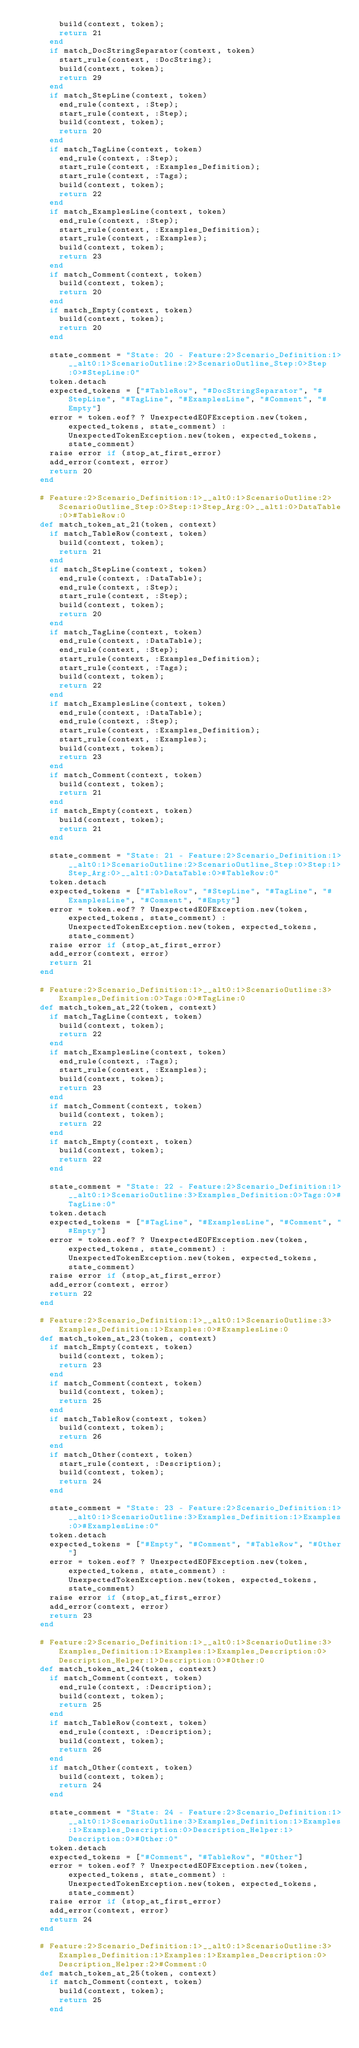Convert code to text. <code><loc_0><loc_0><loc_500><loc_500><_Ruby_>        build(context, token);
        return 21
      end
      if match_DocStringSeparator(context, token)
        start_rule(context, :DocString);
        build(context, token);
        return 29
      end
      if match_StepLine(context, token)
        end_rule(context, :Step);
        start_rule(context, :Step);
        build(context, token);
        return 20
      end
      if match_TagLine(context, token)
        end_rule(context, :Step);
        start_rule(context, :Examples_Definition);
        start_rule(context, :Tags);
        build(context, token);
        return 22
      end
      if match_ExamplesLine(context, token)
        end_rule(context, :Step);
        start_rule(context, :Examples_Definition);
        start_rule(context, :Examples);
        build(context, token);
        return 23
      end
      if match_Comment(context, token)
        build(context, token);
        return 20
      end
      if match_Empty(context, token)
        build(context, token);
        return 20
      end
      
      state_comment = "State: 20 - Feature:2>Scenario_Definition:1>__alt0:1>ScenarioOutline:2>ScenarioOutline_Step:0>Step:0>#StepLine:0"
      token.detach
      expected_tokens = ["#TableRow", "#DocStringSeparator", "#StepLine", "#TagLine", "#ExamplesLine", "#Comment", "#Empty"]
      error = token.eof? ? UnexpectedEOFException.new(token, expected_tokens, state_comment) : UnexpectedTokenException.new(token, expected_tokens, state_comment)
      raise error if (stop_at_first_error)
      add_error(context, error)
      return 20
    end

    # Feature:2>Scenario_Definition:1>__alt0:1>ScenarioOutline:2>ScenarioOutline_Step:0>Step:1>Step_Arg:0>__alt1:0>DataTable:0>#TableRow:0
    def match_token_at_21(token, context)
      if match_TableRow(context, token)
        build(context, token);
        return 21
      end
      if match_StepLine(context, token)
        end_rule(context, :DataTable);
        end_rule(context, :Step);
        start_rule(context, :Step);
        build(context, token);
        return 20
      end
      if match_TagLine(context, token)
        end_rule(context, :DataTable);
        end_rule(context, :Step);
        start_rule(context, :Examples_Definition);
        start_rule(context, :Tags);
        build(context, token);
        return 22
      end
      if match_ExamplesLine(context, token)
        end_rule(context, :DataTable);
        end_rule(context, :Step);
        start_rule(context, :Examples_Definition);
        start_rule(context, :Examples);
        build(context, token);
        return 23
      end
      if match_Comment(context, token)
        build(context, token);
        return 21
      end
      if match_Empty(context, token)
        build(context, token);
        return 21
      end
      
      state_comment = "State: 21 - Feature:2>Scenario_Definition:1>__alt0:1>ScenarioOutline:2>ScenarioOutline_Step:0>Step:1>Step_Arg:0>__alt1:0>DataTable:0>#TableRow:0"
      token.detach
      expected_tokens = ["#TableRow", "#StepLine", "#TagLine", "#ExamplesLine", "#Comment", "#Empty"]
      error = token.eof? ? UnexpectedEOFException.new(token, expected_tokens, state_comment) : UnexpectedTokenException.new(token, expected_tokens, state_comment)
      raise error if (stop_at_first_error)
      add_error(context, error)
      return 21
    end

    # Feature:2>Scenario_Definition:1>__alt0:1>ScenarioOutline:3>Examples_Definition:0>Tags:0>#TagLine:0
    def match_token_at_22(token, context)
      if match_TagLine(context, token)
        build(context, token);
        return 22
      end
      if match_ExamplesLine(context, token)
        end_rule(context, :Tags);
        start_rule(context, :Examples);
        build(context, token);
        return 23
      end
      if match_Comment(context, token)
        build(context, token);
        return 22
      end
      if match_Empty(context, token)
        build(context, token);
        return 22
      end
      
      state_comment = "State: 22 - Feature:2>Scenario_Definition:1>__alt0:1>ScenarioOutline:3>Examples_Definition:0>Tags:0>#TagLine:0"
      token.detach
      expected_tokens = ["#TagLine", "#ExamplesLine", "#Comment", "#Empty"]
      error = token.eof? ? UnexpectedEOFException.new(token, expected_tokens, state_comment) : UnexpectedTokenException.new(token, expected_tokens, state_comment)
      raise error if (stop_at_first_error)
      add_error(context, error)
      return 22
    end

    # Feature:2>Scenario_Definition:1>__alt0:1>ScenarioOutline:3>Examples_Definition:1>Examples:0>#ExamplesLine:0
    def match_token_at_23(token, context)
      if match_Empty(context, token)
        build(context, token);
        return 23
      end
      if match_Comment(context, token)
        build(context, token);
        return 25
      end
      if match_TableRow(context, token)
        build(context, token);
        return 26
      end
      if match_Other(context, token)
        start_rule(context, :Description);
        build(context, token);
        return 24
      end
      
      state_comment = "State: 23 - Feature:2>Scenario_Definition:1>__alt0:1>ScenarioOutline:3>Examples_Definition:1>Examples:0>#ExamplesLine:0"
      token.detach
      expected_tokens = ["#Empty", "#Comment", "#TableRow", "#Other"]
      error = token.eof? ? UnexpectedEOFException.new(token, expected_tokens, state_comment) : UnexpectedTokenException.new(token, expected_tokens, state_comment)
      raise error if (stop_at_first_error)
      add_error(context, error)
      return 23
    end

    # Feature:2>Scenario_Definition:1>__alt0:1>ScenarioOutline:3>Examples_Definition:1>Examples:1>Examples_Description:0>Description_Helper:1>Description:0>#Other:0
    def match_token_at_24(token, context)
      if match_Comment(context, token)
        end_rule(context, :Description);
        build(context, token);
        return 25
      end
      if match_TableRow(context, token)
        end_rule(context, :Description);
        build(context, token);
        return 26
      end
      if match_Other(context, token)
        build(context, token);
        return 24
      end
      
      state_comment = "State: 24 - Feature:2>Scenario_Definition:1>__alt0:1>ScenarioOutline:3>Examples_Definition:1>Examples:1>Examples_Description:0>Description_Helper:1>Description:0>#Other:0"
      token.detach
      expected_tokens = ["#Comment", "#TableRow", "#Other"]
      error = token.eof? ? UnexpectedEOFException.new(token, expected_tokens, state_comment) : UnexpectedTokenException.new(token, expected_tokens, state_comment)
      raise error if (stop_at_first_error)
      add_error(context, error)
      return 24
    end

    # Feature:2>Scenario_Definition:1>__alt0:1>ScenarioOutline:3>Examples_Definition:1>Examples:1>Examples_Description:0>Description_Helper:2>#Comment:0
    def match_token_at_25(token, context)
      if match_Comment(context, token)
        build(context, token);
        return 25
      end</code> 